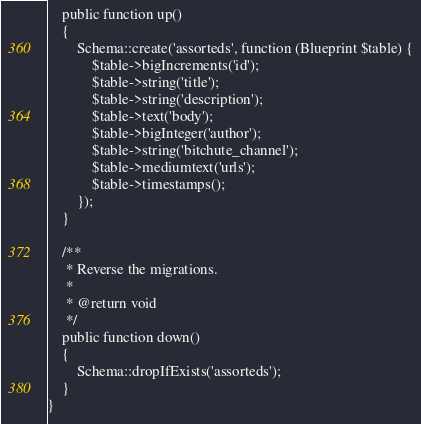Convert code to text. <code><loc_0><loc_0><loc_500><loc_500><_PHP_>    public function up()
    {
        Schema::create('assorteds', function (Blueprint $table) {
            $table->bigIncrements('id');
            $table->string('title');
            $table->string('description');
            $table->text('body');
            $table->bigInteger('author');
            $table->string('bitchute_channel');
            $table->mediumtext('urls');
            $table->timestamps();
        });
    }

    /**
     * Reverse the migrations.
     *
     * @return void
     */
    public function down()
    {
        Schema::dropIfExists('assorteds');
    }
}
</code> 